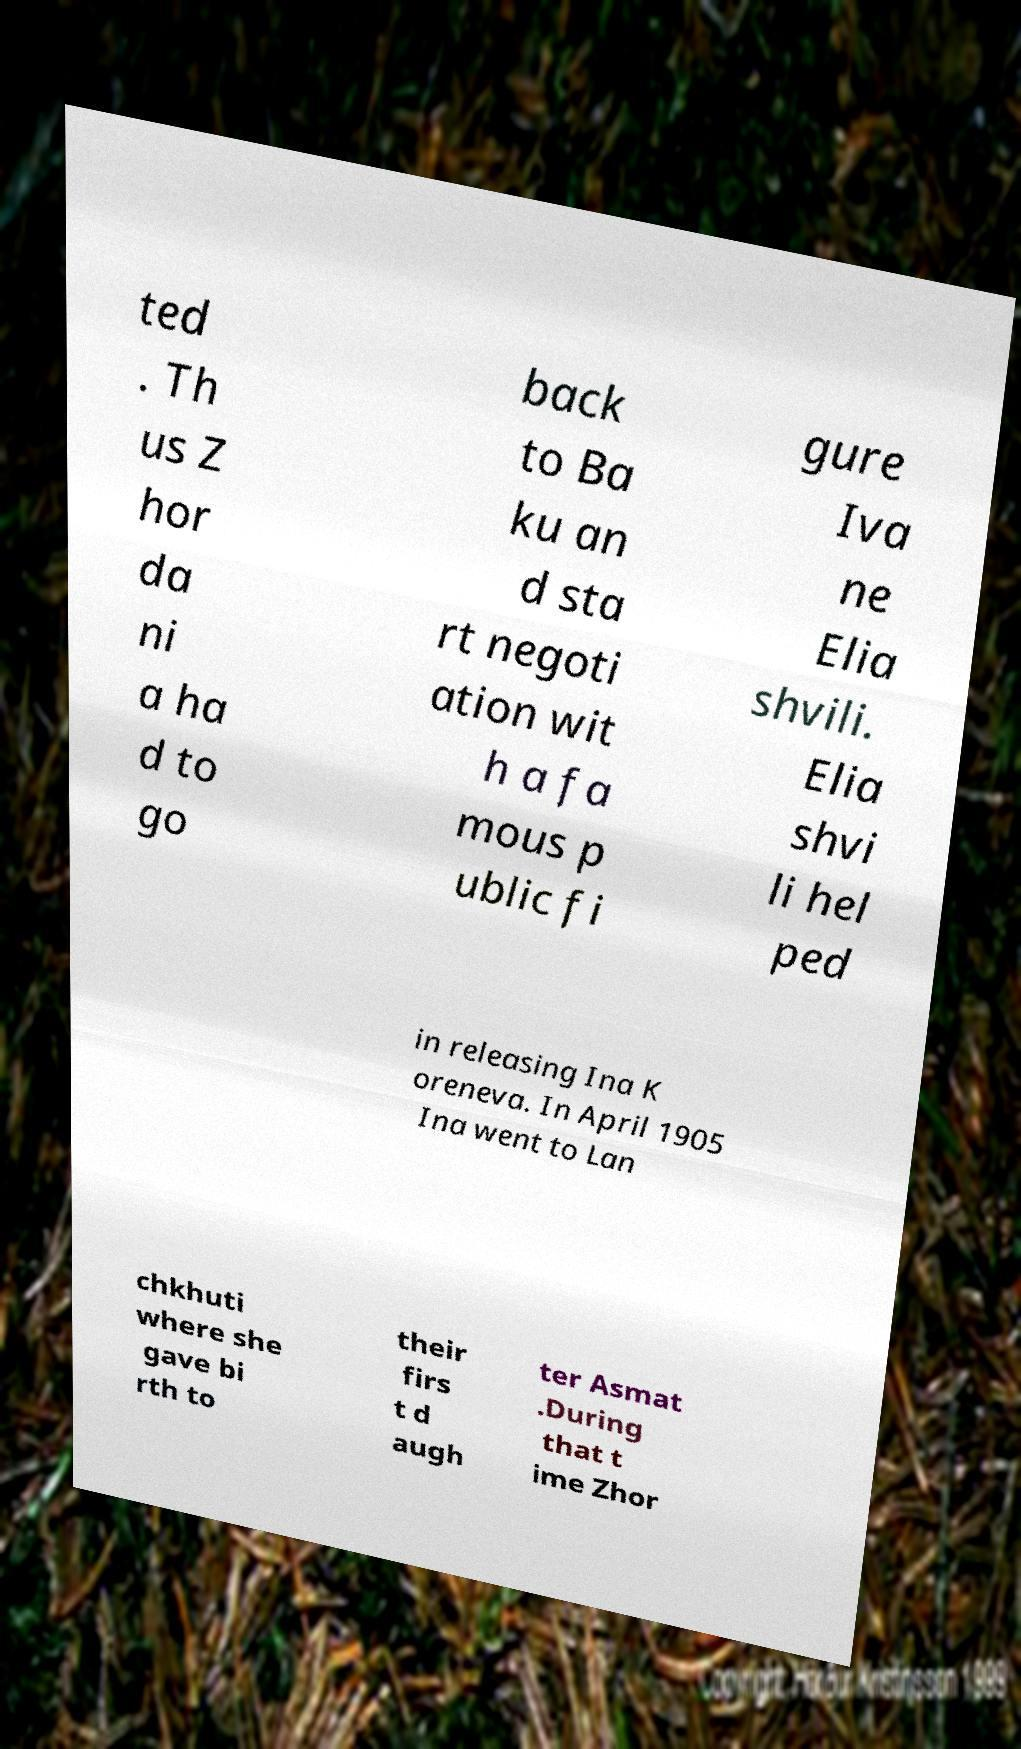Could you extract and type out the text from this image? ted . Th us Z hor da ni a ha d to go back to Ba ku an d sta rt negoti ation wit h a fa mous p ublic fi gure Iva ne Elia shvili. Elia shvi li hel ped in releasing Ina K oreneva. In April 1905 Ina went to Lan chkhuti where she gave bi rth to their firs t d augh ter Asmat .During that t ime Zhor 